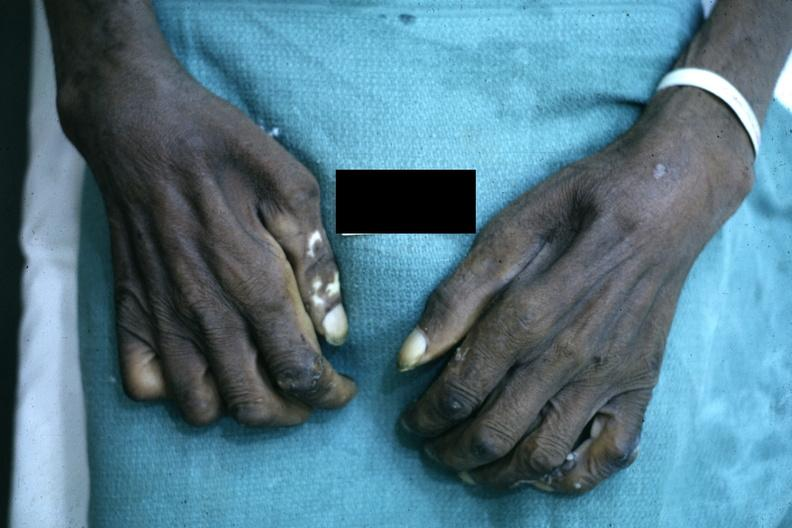why is close-up excellent example of interosseous muscle atrophy said to be?
Answer the question using a single word or phrase. Due syringomyelus 